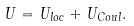<formula> <loc_0><loc_0><loc_500><loc_500>U = U _ { l o c } + U _ { C o u l } .</formula> 